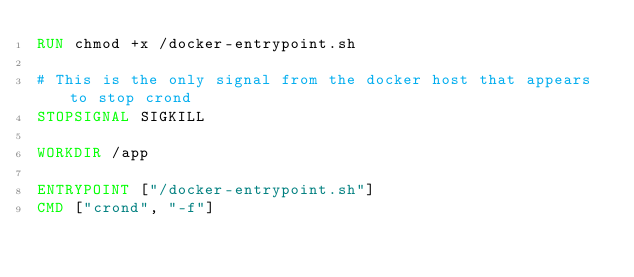Convert code to text. <code><loc_0><loc_0><loc_500><loc_500><_Dockerfile_>RUN chmod +x /docker-entrypoint.sh

# This is the only signal from the docker host that appears to stop crond
STOPSIGNAL SIGKILL

WORKDIR /app

ENTRYPOINT ["/docker-entrypoint.sh"]
CMD ["crond", "-f"]</code> 